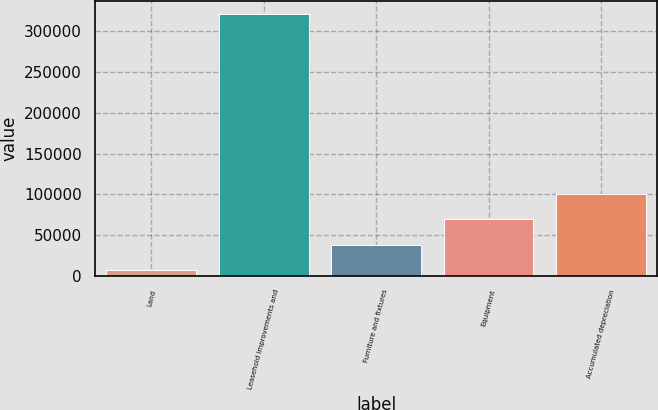Convert chart. <chart><loc_0><loc_0><loc_500><loc_500><bar_chart><fcel>Land<fcel>Leasehold improvements and<fcel>Furniture and fixtures<fcel>Equipment<fcel>Accumulated depreciation<nl><fcel>6557<fcel>320941<fcel>37995.4<fcel>69433.8<fcel>100872<nl></chart> 